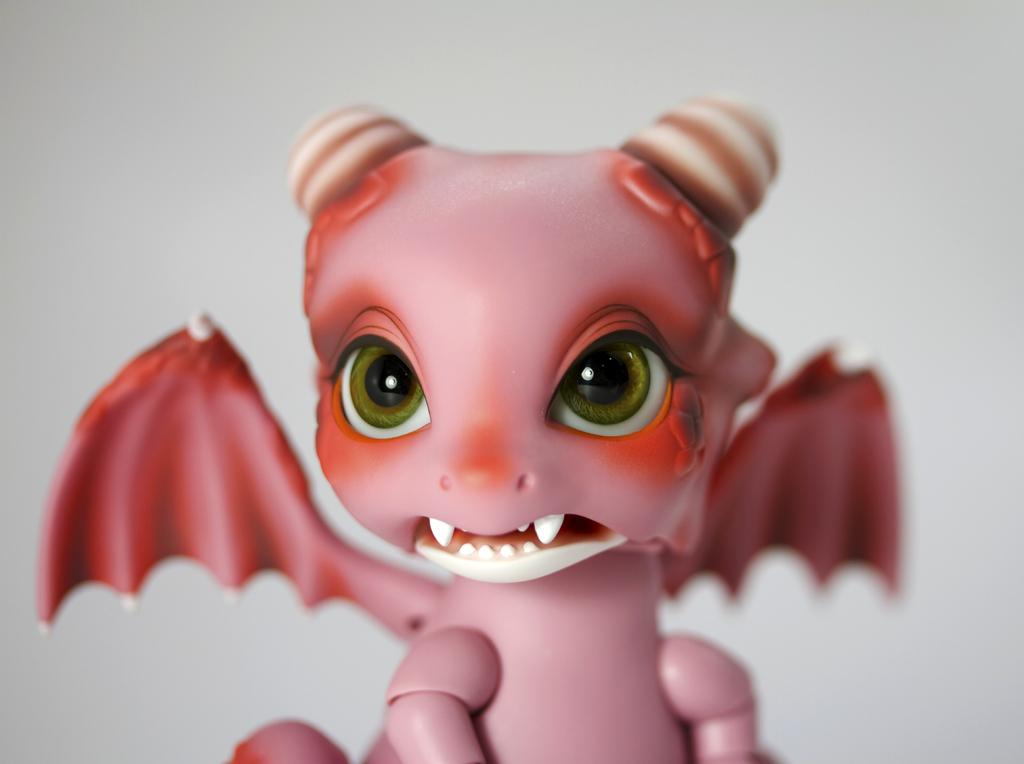What is the color of the toy in the image? The toy in the image is pink. What color is the background of the image? The background of the image is white. What type of wood can be seen being used for writing in the image? There is no wood or writing present in the image. What sign can be seen in the image? There is no sign present in the image. 